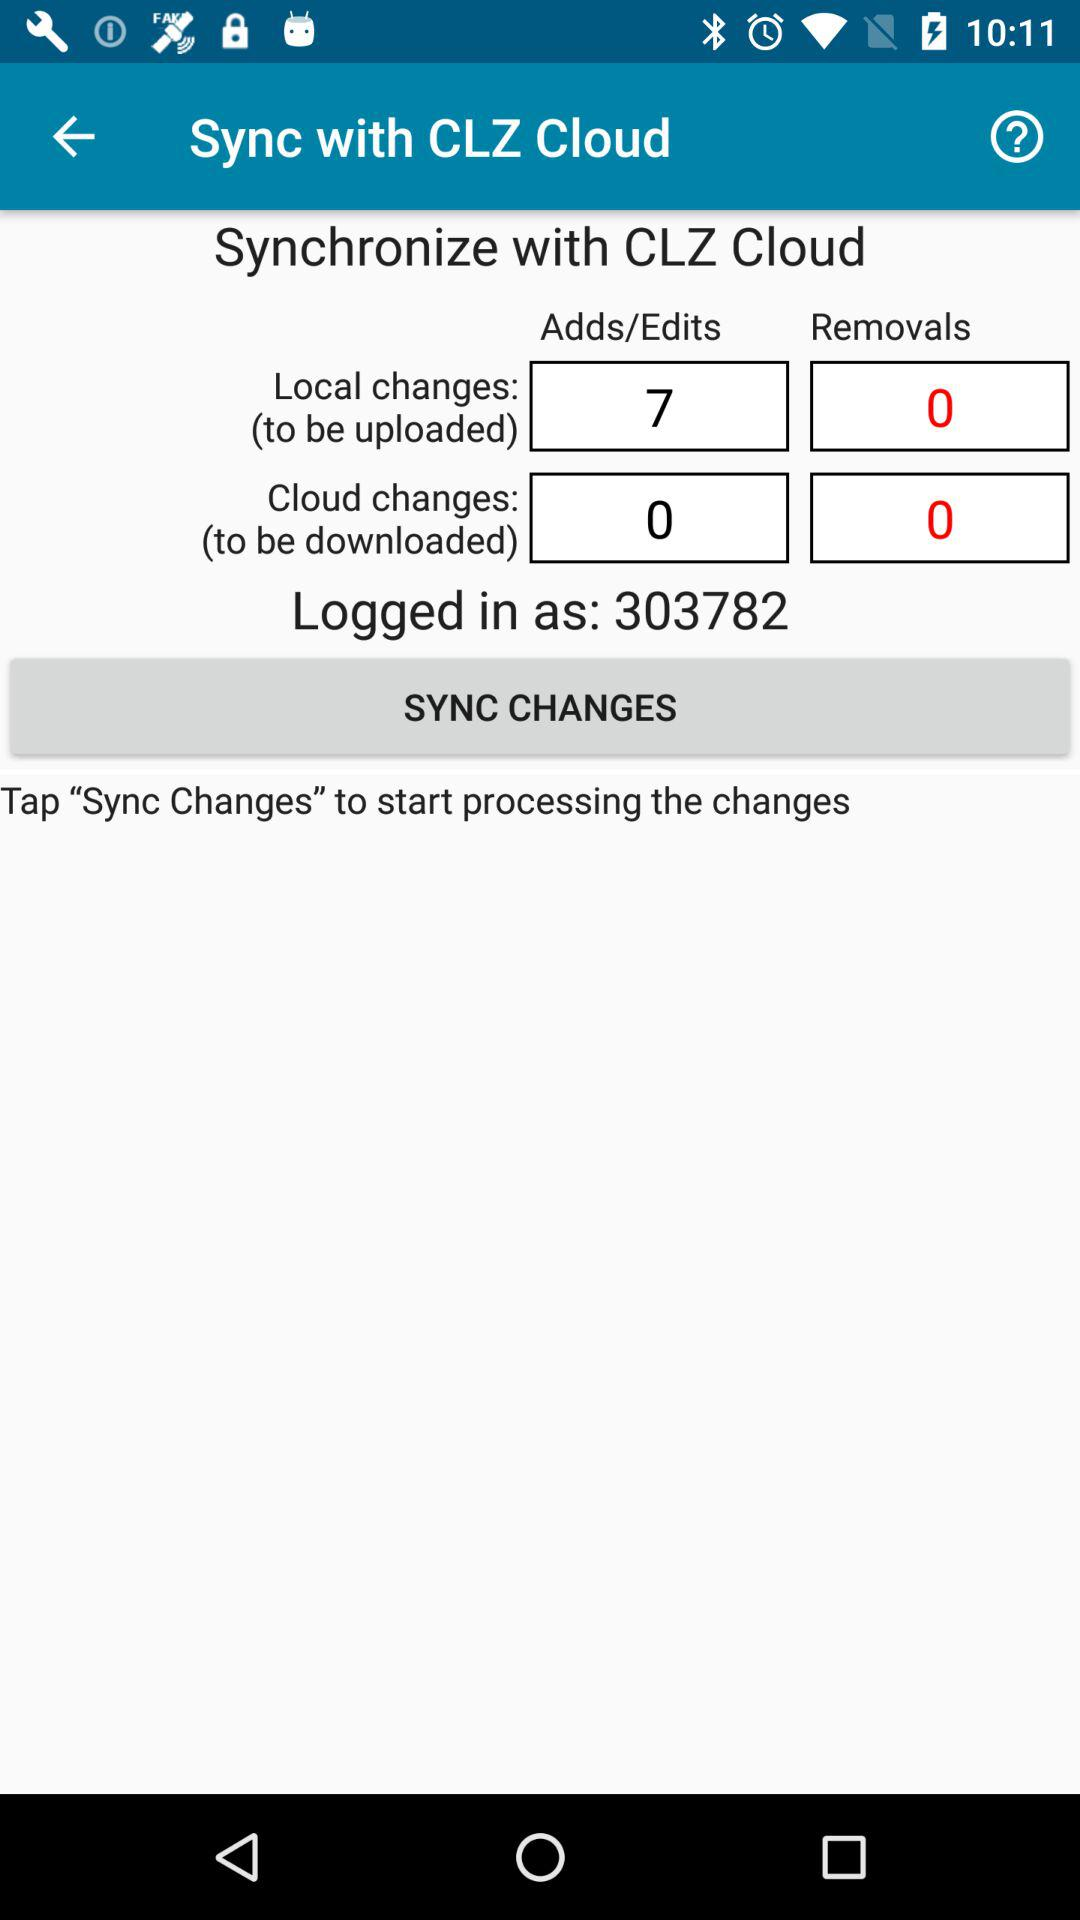What to do to start processing the changes? To start processing the changes, tap "Sync Changes". 